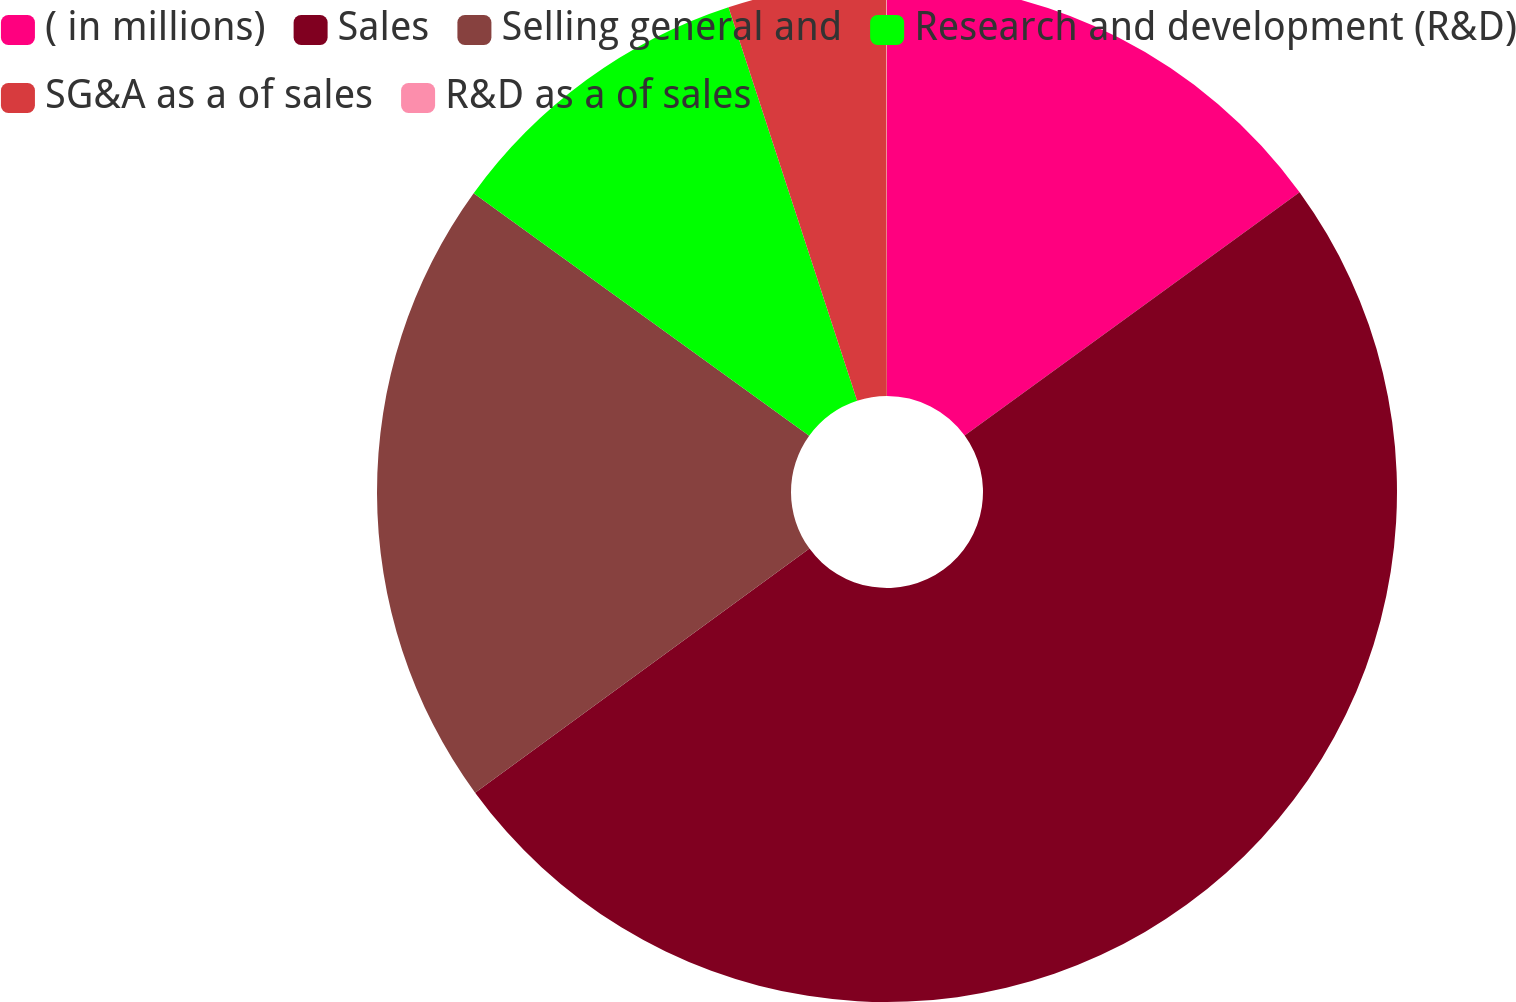<chart> <loc_0><loc_0><loc_500><loc_500><pie_chart><fcel>( in millions)<fcel>Sales<fcel>Selling general and<fcel>Research and development (R&D)<fcel>SG&A as a of sales<fcel>R&D as a of sales<nl><fcel>15.0%<fcel>49.97%<fcel>20.0%<fcel>10.01%<fcel>5.01%<fcel>0.02%<nl></chart> 